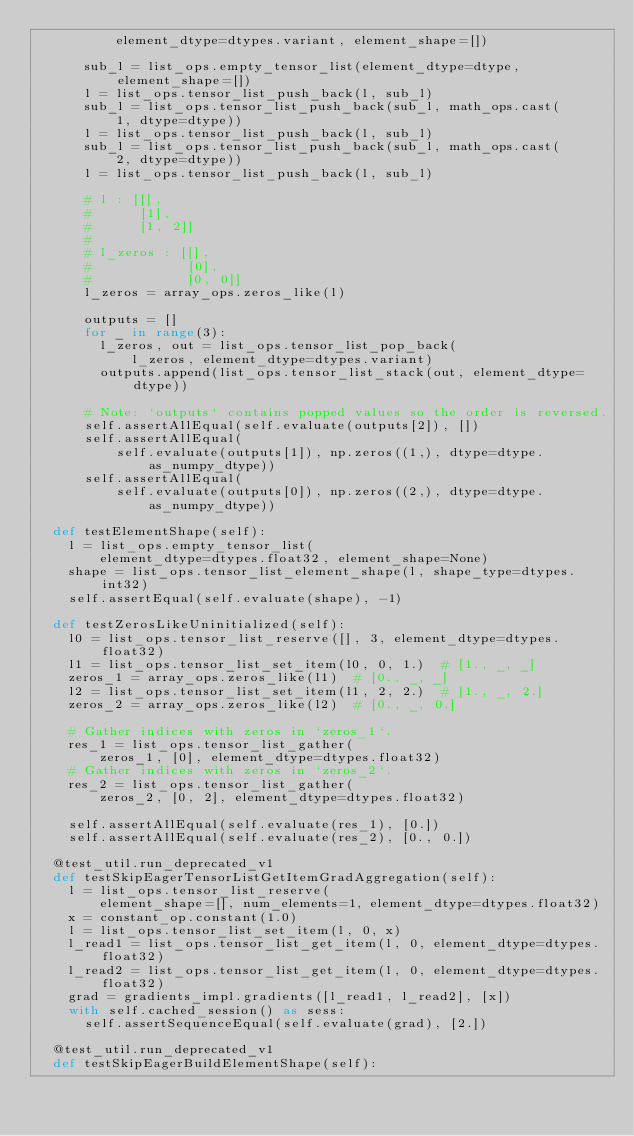Convert code to text. <code><loc_0><loc_0><loc_500><loc_500><_Python_>          element_dtype=dtypes.variant, element_shape=[])

      sub_l = list_ops.empty_tensor_list(element_dtype=dtype, element_shape=[])
      l = list_ops.tensor_list_push_back(l, sub_l)
      sub_l = list_ops.tensor_list_push_back(sub_l, math_ops.cast(
          1, dtype=dtype))
      l = list_ops.tensor_list_push_back(l, sub_l)
      sub_l = list_ops.tensor_list_push_back(sub_l, math_ops.cast(
          2, dtype=dtype))
      l = list_ops.tensor_list_push_back(l, sub_l)

      # l : [[],
      #      [1],
      #      [1, 2]]
      #
      # l_zeros : [[],
      #            [0],
      #            [0, 0]]
      l_zeros = array_ops.zeros_like(l)

      outputs = []
      for _ in range(3):
        l_zeros, out = list_ops.tensor_list_pop_back(
            l_zeros, element_dtype=dtypes.variant)
        outputs.append(list_ops.tensor_list_stack(out, element_dtype=dtype))

      # Note: `outputs` contains popped values so the order is reversed.
      self.assertAllEqual(self.evaluate(outputs[2]), [])
      self.assertAllEqual(
          self.evaluate(outputs[1]), np.zeros((1,), dtype=dtype.as_numpy_dtype))
      self.assertAllEqual(
          self.evaluate(outputs[0]), np.zeros((2,), dtype=dtype.as_numpy_dtype))

  def testElementShape(self):
    l = list_ops.empty_tensor_list(
        element_dtype=dtypes.float32, element_shape=None)
    shape = list_ops.tensor_list_element_shape(l, shape_type=dtypes.int32)
    self.assertEqual(self.evaluate(shape), -1)

  def testZerosLikeUninitialized(self):
    l0 = list_ops.tensor_list_reserve([], 3, element_dtype=dtypes.float32)
    l1 = list_ops.tensor_list_set_item(l0, 0, 1.)  # [1., _, _]
    zeros_1 = array_ops.zeros_like(l1)  # [0., _, _]
    l2 = list_ops.tensor_list_set_item(l1, 2, 2.)  # [1., _, 2.]
    zeros_2 = array_ops.zeros_like(l2)  # [0., _, 0.]

    # Gather indices with zeros in `zeros_1`.
    res_1 = list_ops.tensor_list_gather(
        zeros_1, [0], element_dtype=dtypes.float32)
    # Gather indices with zeros in `zeros_2`.
    res_2 = list_ops.tensor_list_gather(
        zeros_2, [0, 2], element_dtype=dtypes.float32)

    self.assertAllEqual(self.evaluate(res_1), [0.])
    self.assertAllEqual(self.evaluate(res_2), [0., 0.])

  @test_util.run_deprecated_v1
  def testSkipEagerTensorListGetItemGradAggregation(self):
    l = list_ops.tensor_list_reserve(
        element_shape=[], num_elements=1, element_dtype=dtypes.float32)
    x = constant_op.constant(1.0)
    l = list_ops.tensor_list_set_item(l, 0, x)
    l_read1 = list_ops.tensor_list_get_item(l, 0, element_dtype=dtypes.float32)
    l_read2 = list_ops.tensor_list_get_item(l, 0, element_dtype=dtypes.float32)
    grad = gradients_impl.gradients([l_read1, l_read2], [x])
    with self.cached_session() as sess:
      self.assertSequenceEqual(self.evaluate(grad), [2.])

  @test_util.run_deprecated_v1
  def testSkipEagerBuildElementShape(self):</code> 